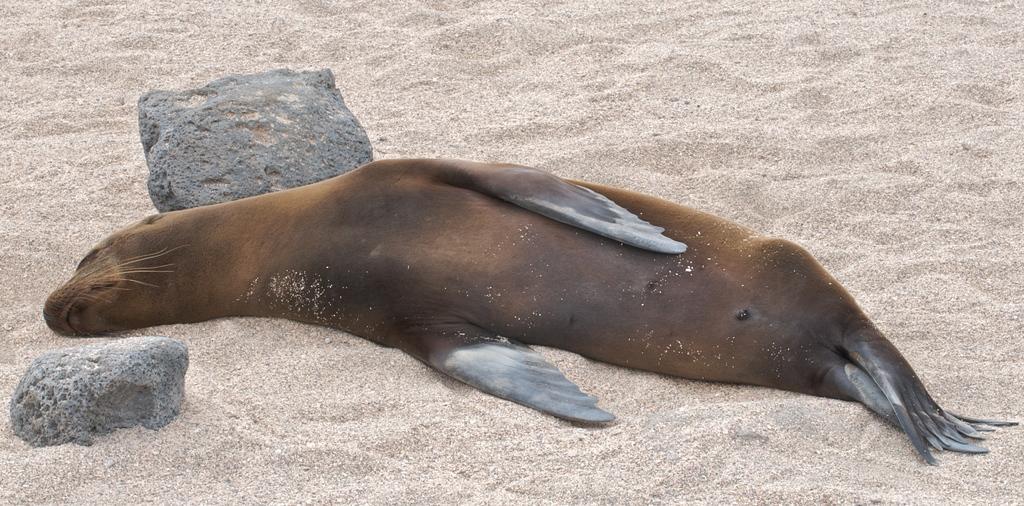How would you summarize this image in a sentence or two? In the image there is a seal laying on the beach with two stones on either side of it. 